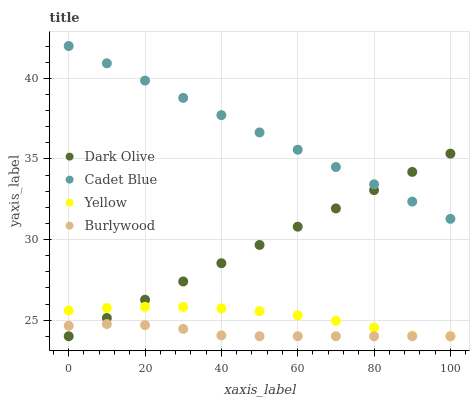Does Burlywood have the minimum area under the curve?
Answer yes or no. Yes. Does Cadet Blue have the maximum area under the curve?
Answer yes or no. Yes. Does Dark Olive have the minimum area under the curve?
Answer yes or no. No. Does Dark Olive have the maximum area under the curve?
Answer yes or no. No. Is Dark Olive the smoothest?
Answer yes or no. Yes. Is Yellow the roughest?
Answer yes or no. Yes. Is Burlywood the smoothest?
Answer yes or no. No. Is Burlywood the roughest?
Answer yes or no. No. Does Burlywood have the lowest value?
Answer yes or no. Yes. Does Cadet Blue have the highest value?
Answer yes or no. Yes. Does Dark Olive have the highest value?
Answer yes or no. No. Is Burlywood less than Cadet Blue?
Answer yes or no. Yes. Is Cadet Blue greater than Yellow?
Answer yes or no. Yes. Does Yellow intersect Dark Olive?
Answer yes or no. Yes. Is Yellow less than Dark Olive?
Answer yes or no. No. Is Yellow greater than Dark Olive?
Answer yes or no. No. Does Burlywood intersect Cadet Blue?
Answer yes or no. No. 